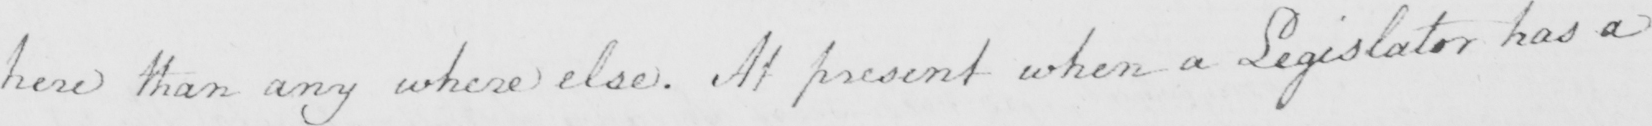Please transcribe the handwritten text in this image. here than any where else . At present when a Legislator has a 